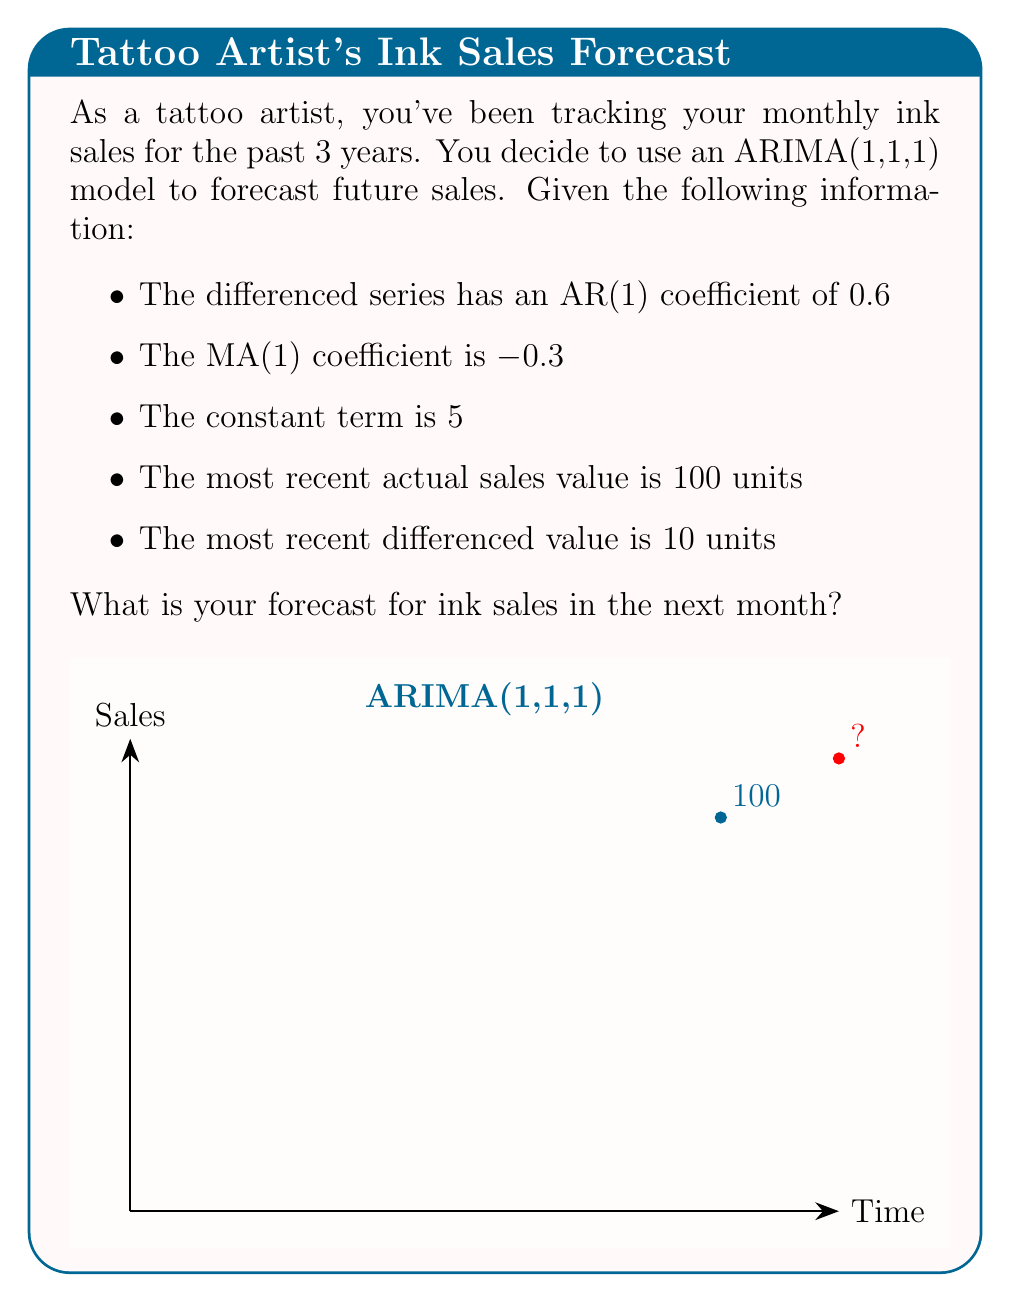Can you answer this question? Let's approach this step-by-step using the ARIMA(1,1,1) model:

1) The general form of an ARIMA(1,1,1) model is:

   $$(1-\phi B)(1-B)y_t = c + (1+\theta B)\epsilon_t$$

   where $\phi$ is the AR(1) coefficient, $\theta$ is the MA(1) coefficient, $c$ is the constant term, and $B$ is the backshift operator.

2) For forecasting one step ahead, we use the equation:

   $$\hat{y}_{t+1} = y_t + \phi(y_t - y_{t-1}) + c + \theta\epsilon_t$$

3) We're given:
   - $\phi = 0.6$
   - $\theta = -0.3$
   - $c = 5$
   - $y_t = 100$ (most recent actual sales)
   - $(y_t - y_{t-1}) = 10$ (most recent differenced value)

4) We don't know $\epsilon_t$, but for forecasting purposes, we assume it's zero.

5) Plugging these values into our equation:

   $$\hat{y}_{t+1} = 100 + 0.6(10) + 5 + (-0.3)(0)$$

6) Simplifying:

   $$\hat{y}_{t+1} = 100 + 6 + 5 = 111$$

Therefore, the forecast for ink sales in the next month is 111 units.
Answer: 111 units 